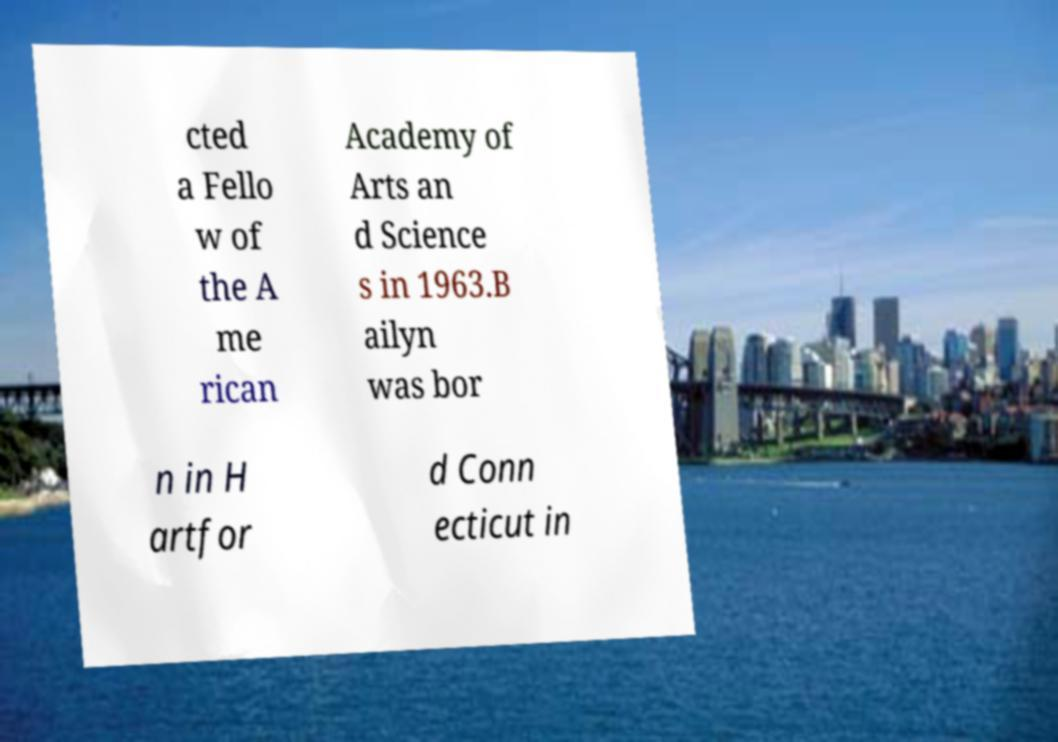What messages or text are displayed in this image? I need them in a readable, typed format. cted a Fello w of the A me rican Academy of Arts an d Science s in 1963.B ailyn was bor n in H artfor d Conn ecticut in 